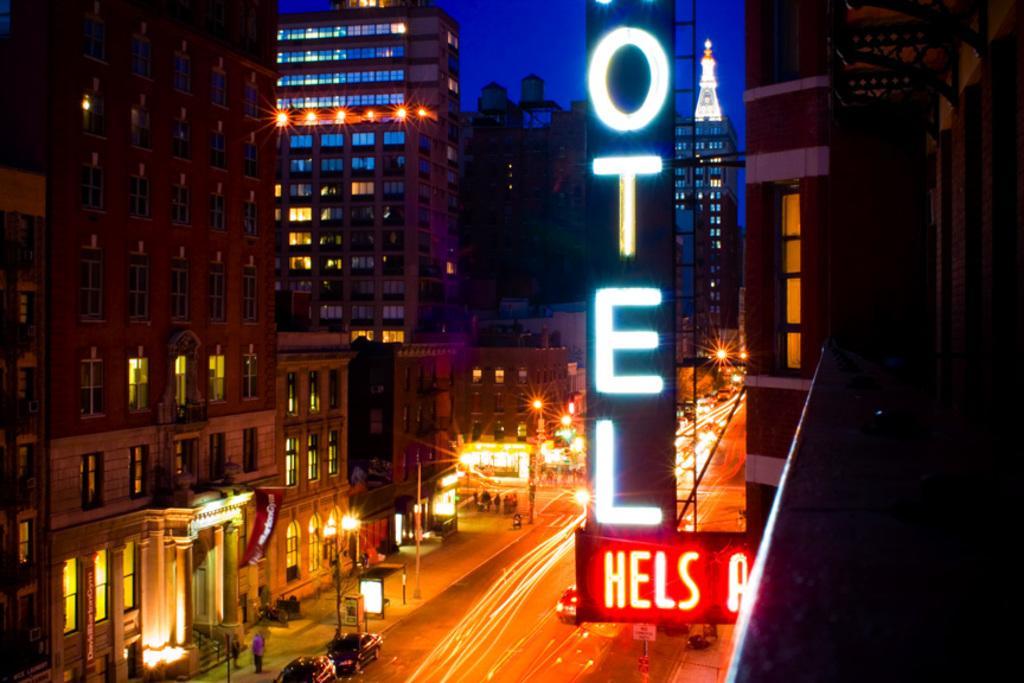Can you describe this image briefly? In this image I can see few buildings, few lights, few boards, the road, few vehicles on the road, the sidewalk, few poles and few persons on the sidewalk. In the background I can see the sky. 